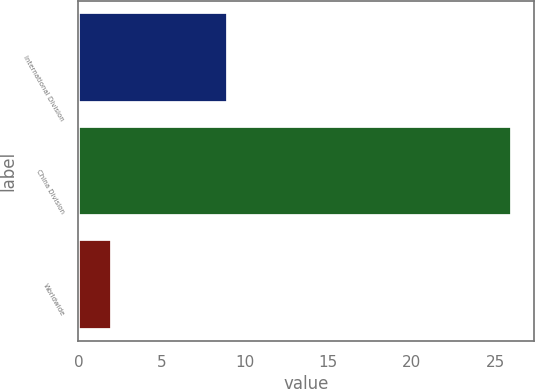Convert chart to OTSL. <chart><loc_0><loc_0><loc_500><loc_500><bar_chart><fcel>International Division<fcel>China Division<fcel>Worldwide<nl><fcel>9<fcel>26<fcel>2<nl></chart> 